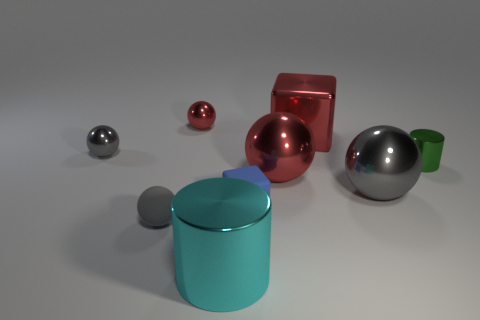Subtract all gray balls. How many balls are left? 2 Subtract all small gray metal spheres. How many spheres are left? 4 Subtract 3 spheres. How many spheres are left? 2 Subtract all spheres. How many objects are left? 4 Subtract all brown spheres. How many brown cylinders are left? 0 Subtract 0 yellow cylinders. How many objects are left? 9 Subtract all green cylinders. Subtract all brown blocks. How many cylinders are left? 1 Subtract all cyan metallic cylinders. Subtract all tiny gray shiny spheres. How many objects are left? 7 Add 3 small gray rubber spheres. How many small gray rubber spheres are left? 4 Add 2 red metallic objects. How many red metallic objects exist? 5 